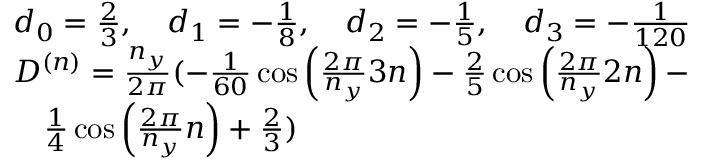<formula> <loc_0><loc_0><loc_500><loc_500>\begin{array} { r l } & { d _ { 0 } = \frac { 2 } { 3 } , \quad d _ { 1 } = - \frac { 1 } { 8 } , \quad d _ { 2 } = - \frac { 1 } { 5 } , \quad d _ { 3 } = - \frac { 1 } { 1 2 0 } } \\ & { D ^ { ( n ) } = \frac { n _ { y } } { 2 \pi } ( - \frac { 1 } { 6 0 } \cos \left ( \frac { 2 \pi } { n _ { y } } 3 n \right ) - \frac { 2 } { 5 } \cos \left ( \frac { 2 \pi } { n _ { y } } 2 n \right ) - } \\ & { \quad \frac { 1 } { 4 } \cos \left ( \frac { 2 \pi } { n _ { y } } n \right ) + \frac { 2 } { 3 } ) } \end{array}</formula> 